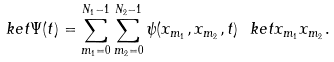<formula> <loc_0><loc_0><loc_500><loc_500>\ k e t { \Psi ( t ) } = \sum _ { m _ { 1 } = 0 } ^ { N _ { 1 } - 1 } \sum _ { m _ { 2 } = 0 } ^ { N _ { 2 } - 1 } \psi ( x _ { m _ { 1 } } , x _ { m _ { 2 } } , t ) \ k e t { x _ { m _ { 1 } } x _ { m _ { 2 } } } .</formula> 